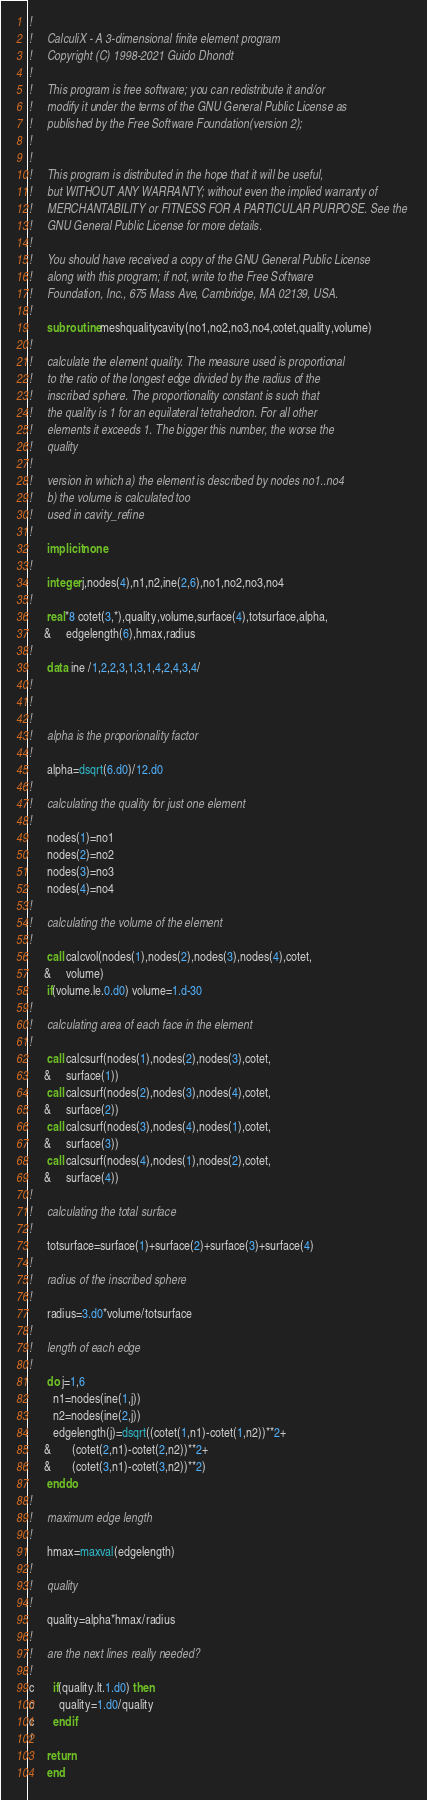<code> <loc_0><loc_0><loc_500><loc_500><_FORTRAN_>!     
!     CalculiX - A 3-dimensional finite element program
!     Copyright (C) 1998-2021 Guido Dhondt
!     
!     This program is free software; you can redistribute it and/or
!     modify it under the terms of the GNU General Public License as
!     published by the Free Software Foundation(version 2);
!     
!     
!     This program is distributed in the hope that it will be useful,
!     but WITHOUT ANY WARRANTY; without even the implied warranty of 
!     MERCHANTABILITY or FITNESS FOR A PARTICULAR PURPOSE. See the 
!     GNU General Public License for more details.
!     
!     You should have received a copy of the GNU General Public License
!     along with this program; if not, write to the Free Software
!     Foundation, Inc., 675 Mass Ave, Cambridge, MA 02139, USA.
!     
      subroutine meshqualitycavity(no1,no2,no3,no4,cotet,quality,volume)
!     
!     calculate the element quality. The measure used is proportional
!     to the ratio of the longest edge divided by the radius of the
!     inscribed sphere. The proportionality constant is such that
!     the quality is 1 for an equilateral tetrahedron. For all other
!     elements it exceeds 1. The bigger this number, the worse the
!     quality
!     
!     version in which a) the element is described by nodes no1..no4
!     b) the volume is calculated too
!     used in cavity_refine      
!     
      implicit none
!     
      integer j,nodes(4),n1,n2,ine(2,6),no1,no2,no3,no4
!     
      real*8 cotet(3,*),quality,volume,surface(4),totsurface,alpha,
     &     edgelength(6),hmax,radius
!     
      data ine /1,2,2,3,1,3,1,4,2,4,3,4/
!     
!     
!     
!     alpha is the proporionality factor
!     
      alpha=dsqrt(6.d0)/12.d0
!     
!     calculating the quality for just one element
!     
      nodes(1)=no1
      nodes(2)=no2
      nodes(3)=no3
      nodes(4)=no4
!     
!     calculating the volume of the element
!     
      call calcvol(nodes(1),nodes(2),nodes(3),nodes(4),cotet,
     &     volume)
      if(volume.le.0.d0) volume=1.d-30
!     
!     calculating area of each face in the element
!     
      call calcsurf(nodes(1),nodes(2),nodes(3),cotet,
     &     surface(1))
      call calcsurf(nodes(2),nodes(3),nodes(4),cotet,
     &     surface(2))
      call calcsurf(nodes(3),nodes(4),nodes(1),cotet,
     &     surface(3))
      call calcsurf(nodes(4),nodes(1),nodes(2),cotet,
     &     surface(4))
!     
!     calculating the total surface
!     
      totsurface=surface(1)+surface(2)+surface(3)+surface(4)
!     
!     radius of the inscribed sphere
!     
      radius=3.d0*volume/totsurface
!     
!     length of each edge
!     
      do j=1,6
        n1=nodes(ine(1,j))
        n2=nodes(ine(2,j))
        edgelength(j)=dsqrt((cotet(1,n1)-cotet(1,n2))**2+
     &       (cotet(2,n1)-cotet(2,n2))**2+
     &       (cotet(3,n1)-cotet(3,n2))**2)
      enddo
!     
!     maximum edge length
!     
      hmax=maxval(edgelength)
!     
!     quality
!     
      quality=alpha*hmax/radius
!     
!     are the next lines really needed?
!     
c      if(quality.lt.1.d0) then
c        quality=1.d0/quality
c      endif
!     
      return
      end
</code> 